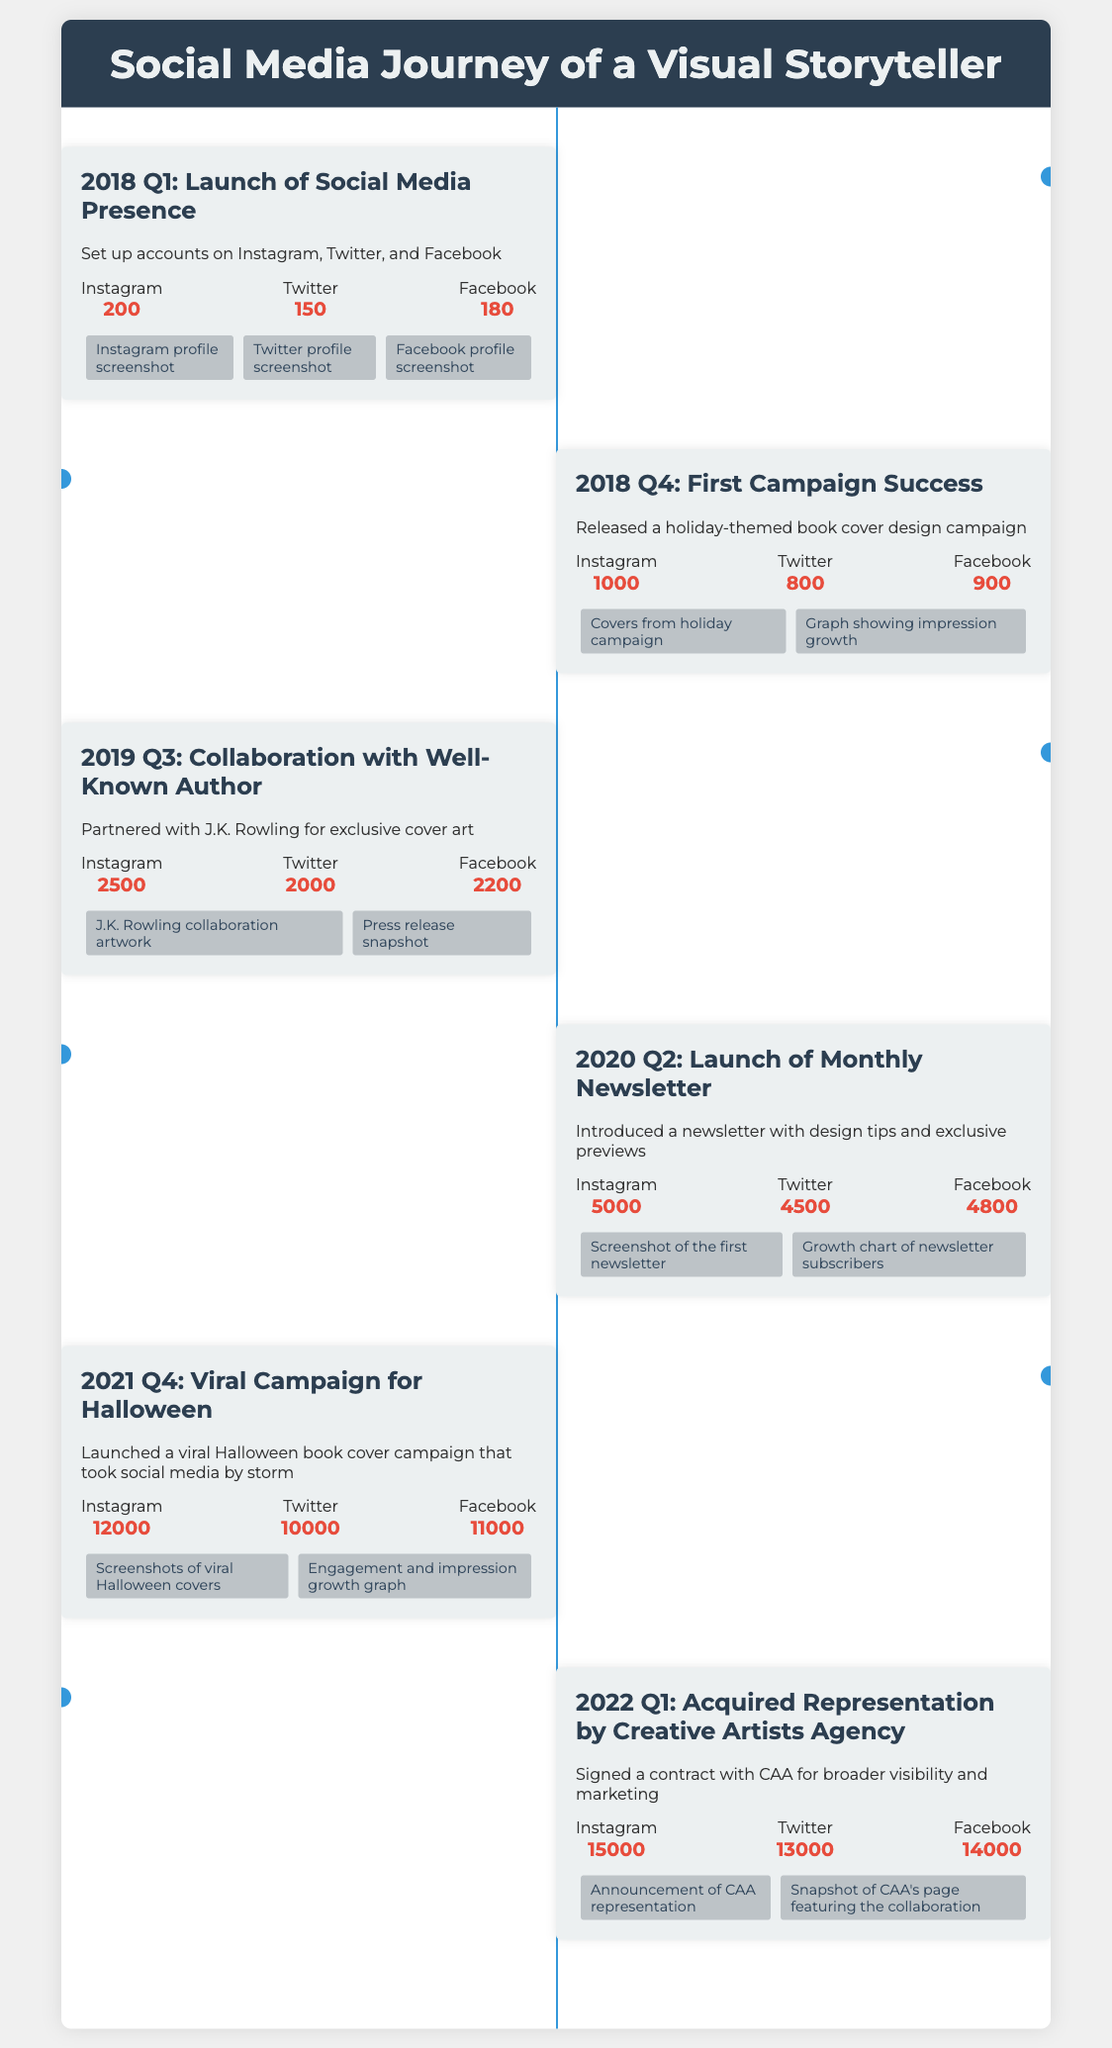what year did the social media presence launch? The document states that the social media presence was launched in the first quarter of 2018.
Answer: 2018 Q1 how many followers did Instagram have at the end of the first campaign? At the end of the first campaign in 2018 Q4, Instagram had 1000 followers.
Answer: 1000 what was the total follower count on Twitter in 2021 Q4? The document shows that Twitter had 10000 followers in 2021 Q4.
Answer: 10000 who was the collaborating author in 2019 Q3? The document mentions J.K. Rowling as the collaborating author in 2019 Q3.
Answer: J.K. Rowling which agency was the writer represented by in 2022 Q1? The representation agency mentioned in the document is Creative Artists Agency.
Answer: Creative Artists Agency what notable campaign occurred in 2021 Q4? The document highlights a viral Halloween campaign in 2021 Q4.
Answer: Halloween campaign which quarter introduced the monthly newsletter? The monthly newsletter was launched in 2020 Q2 as per the document.
Answer: 2020 Q2 how many Facebook followers were there in 2022 Q1? The document specifies that there were 14000 Facebook followers in 2022 Q1.
Answer: 14000 what visual element accompanied the first campaign success? The visual elements included covers from the holiday campaign.
Answer: Covers from holiday campaign 